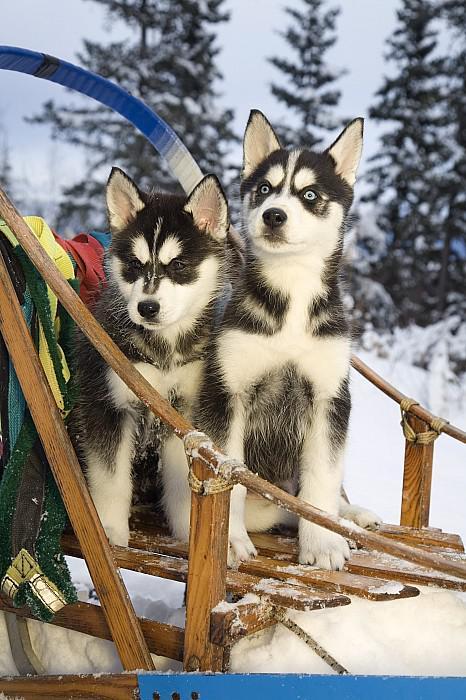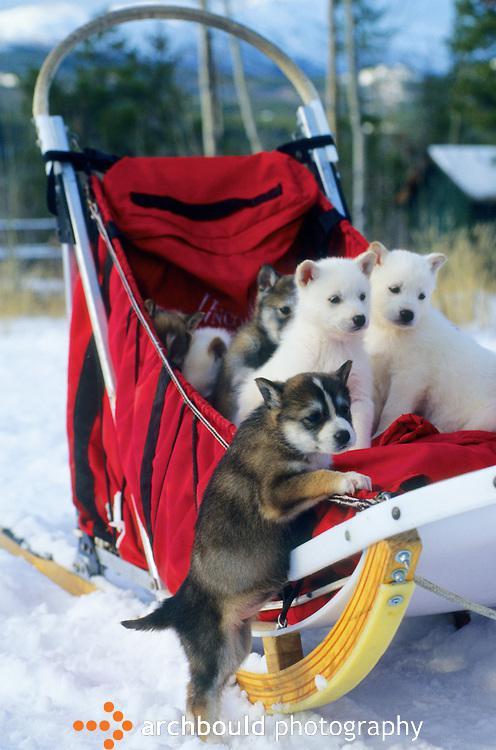The first image is the image on the left, the second image is the image on the right. For the images displayed, is the sentence "Two dogs sit on a wooden structure in the image on the left." factually correct? Answer yes or no. Yes. The first image is the image on the left, the second image is the image on the right. Considering the images on both sides, is "Each image shows at least one dog in a sled, and one image features at least three young puppies in a sled with something red behind them." valid? Answer yes or no. Yes. 